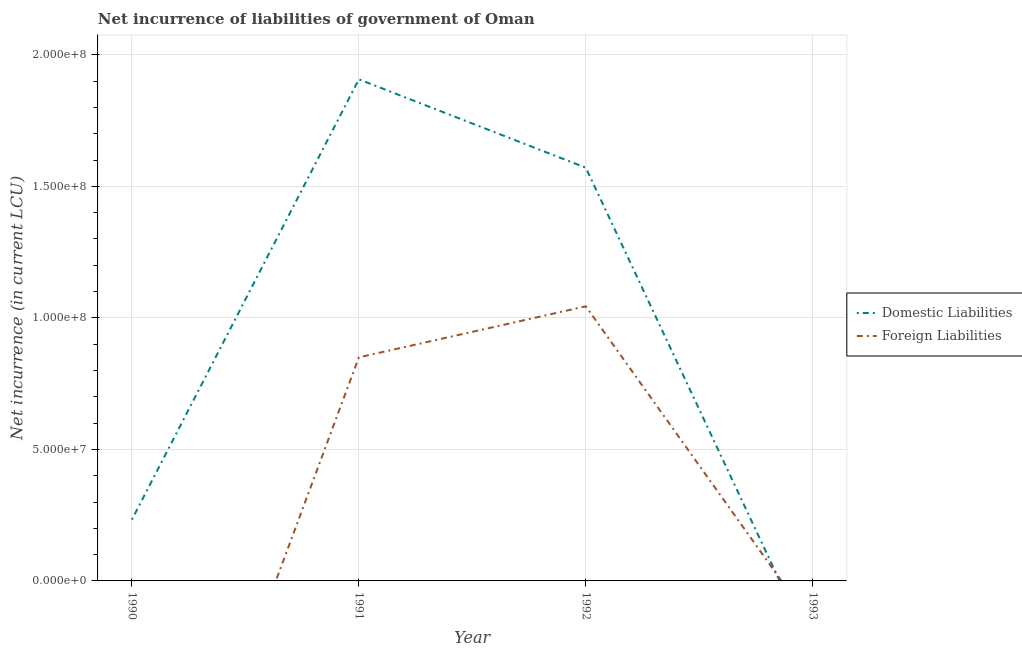How many different coloured lines are there?
Your answer should be very brief. 2. Does the line corresponding to net incurrence of foreign liabilities intersect with the line corresponding to net incurrence of domestic liabilities?
Provide a short and direct response. Yes. Is the number of lines equal to the number of legend labels?
Offer a terse response. No. Across all years, what is the maximum net incurrence of foreign liabilities?
Offer a terse response. 1.04e+08. In which year was the net incurrence of foreign liabilities maximum?
Provide a short and direct response. 1992. What is the total net incurrence of domestic liabilities in the graph?
Your response must be concise. 3.71e+08. What is the difference between the net incurrence of domestic liabilities in 1990 and that in 1991?
Ensure brevity in your answer.  -1.67e+08. What is the difference between the net incurrence of domestic liabilities in 1992 and the net incurrence of foreign liabilities in 1990?
Provide a succinct answer. 1.57e+08. What is the average net incurrence of domestic liabilities per year?
Provide a short and direct response. 9.28e+07. In the year 1991, what is the difference between the net incurrence of foreign liabilities and net incurrence of domestic liabilities?
Offer a very short reply. -1.06e+08. In how many years, is the net incurrence of domestic liabilities greater than 140000000 LCU?
Make the answer very short. 2. What is the ratio of the net incurrence of domestic liabilities in 1990 to that in 1992?
Keep it short and to the point. 0.15. Is the net incurrence of domestic liabilities in 1990 less than that in 1991?
Your response must be concise. Yes. What is the difference between the highest and the second highest net incurrence of domestic liabilities?
Keep it short and to the point. 3.36e+07. What is the difference between the highest and the lowest net incurrence of foreign liabilities?
Offer a very short reply. 1.04e+08. Is the sum of the net incurrence of domestic liabilities in 1990 and 1992 greater than the maximum net incurrence of foreign liabilities across all years?
Your answer should be very brief. Yes. Is the net incurrence of foreign liabilities strictly greater than the net incurrence of domestic liabilities over the years?
Keep it short and to the point. No. Is the net incurrence of foreign liabilities strictly less than the net incurrence of domestic liabilities over the years?
Your response must be concise. No. How many years are there in the graph?
Make the answer very short. 4. Are the values on the major ticks of Y-axis written in scientific E-notation?
Ensure brevity in your answer.  Yes. Does the graph contain grids?
Ensure brevity in your answer.  Yes. How many legend labels are there?
Your response must be concise. 2. How are the legend labels stacked?
Provide a succinct answer. Vertical. What is the title of the graph?
Your answer should be very brief. Net incurrence of liabilities of government of Oman. Does "Male labourers" appear as one of the legend labels in the graph?
Keep it short and to the point. No. What is the label or title of the Y-axis?
Give a very brief answer. Net incurrence (in current LCU). What is the Net incurrence (in current LCU) of Domestic Liabilities in 1990?
Your answer should be very brief. 2.33e+07. What is the Net incurrence (in current LCU) in Foreign Liabilities in 1990?
Make the answer very short. 0. What is the Net incurrence (in current LCU) in Domestic Liabilities in 1991?
Your answer should be very brief. 1.91e+08. What is the Net incurrence (in current LCU) in Foreign Liabilities in 1991?
Provide a succinct answer. 8.50e+07. What is the Net incurrence (in current LCU) in Domestic Liabilities in 1992?
Offer a very short reply. 1.57e+08. What is the Net incurrence (in current LCU) in Foreign Liabilities in 1992?
Offer a very short reply. 1.04e+08. Across all years, what is the maximum Net incurrence (in current LCU) of Domestic Liabilities?
Your answer should be compact. 1.91e+08. Across all years, what is the maximum Net incurrence (in current LCU) in Foreign Liabilities?
Give a very brief answer. 1.04e+08. Across all years, what is the minimum Net incurrence (in current LCU) in Domestic Liabilities?
Give a very brief answer. 0. Across all years, what is the minimum Net incurrence (in current LCU) of Foreign Liabilities?
Provide a succinct answer. 0. What is the total Net incurrence (in current LCU) in Domestic Liabilities in the graph?
Make the answer very short. 3.71e+08. What is the total Net incurrence (in current LCU) of Foreign Liabilities in the graph?
Offer a terse response. 1.89e+08. What is the difference between the Net incurrence (in current LCU) in Domestic Liabilities in 1990 and that in 1991?
Keep it short and to the point. -1.67e+08. What is the difference between the Net incurrence (in current LCU) of Domestic Liabilities in 1990 and that in 1992?
Provide a short and direct response. -1.34e+08. What is the difference between the Net incurrence (in current LCU) in Domestic Liabilities in 1991 and that in 1992?
Provide a short and direct response. 3.36e+07. What is the difference between the Net incurrence (in current LCU) of Foreign Liabilities in 1991 and that in 1992?
Your answer should be compact. -1.94e+07. What is the difference between the Net incurrence (in current LCU) of Domestic Liabilities in 1990 and the Net incurrence (in current LCU) of Foreign Liabilities in 1991?
Make the answer very short. -6.17e+07. What is the difference between the Net incurrence (in current LCU) in Domestic Liabilities in 1990 and the Net incurrence (in current LCU) in Foreign Liabilities in 1992?
Your answer should be compact. -8.11e+07. What is the difference between the Net incurrence (in current LCU) in Domestic Liabilities in 1991 and the Net incurrence (in current LCU) in Foreign Liabilities in 1992?
Your answer should be compact. 8.63e+07. What is the average Net incurrence (in current LCU) of Domestic Liabilities per year?
Keep it short and to the point. 9.28e+07. What is the average Net incurrence (in current LCU) of Foreign Liabilities per year?
Ensure brevity in your answer.  4.74e+07. In the year 1991, what is the difference between the Net incurrence (in current LCU) in Domestic Liabilities and Net incurrence (in current LCU) in Foreign Liabilities?
Provide a succinct answer. 1.06e+08. In the year 1992, what is the difference between the Net incurrence (in current LCU) in Domestic Liabilities and Net incurrence (in current LCU) in Foreign Liabilities?
Offer a terse response. 5.27e+07. What is the ratio of the Net incurrence (in current LCU) of Domestic Liabilities in 1990 to that in 1991?
Your answer should be very brief. 0.12. What is the ratio of the Net incurrence (in current LCU) in Domestic Liabilities in 1990 to that in 1992?
Offer a very short reply. 0.15. What is the ratio of the Net incurrence (in current LCU) of Domestic Liabilities in 1991 to that in 1992?
Offer a terse response. 1.21. What is the ratio of the Net incurrence (in current LCU) of Foreign Liabilities in 1991 to that in 1992?
Offer a terse response. 0.81. What is the difference between the highest and the second highest Net incurrence (in current LCU) of Domestic Liabilities?
Your response must be concise. 3.36e+07. What is the difference between the highest and the lowest Net incurrence (in current LCU) in Domestic Liabilities?
Provide a short and direct response. 1.91e+08. What is the difference between the highest and the lowest Net incurrence (in current LCU) in Foreign Liabilities?
Offer a very short reply. 1.04e+08. 